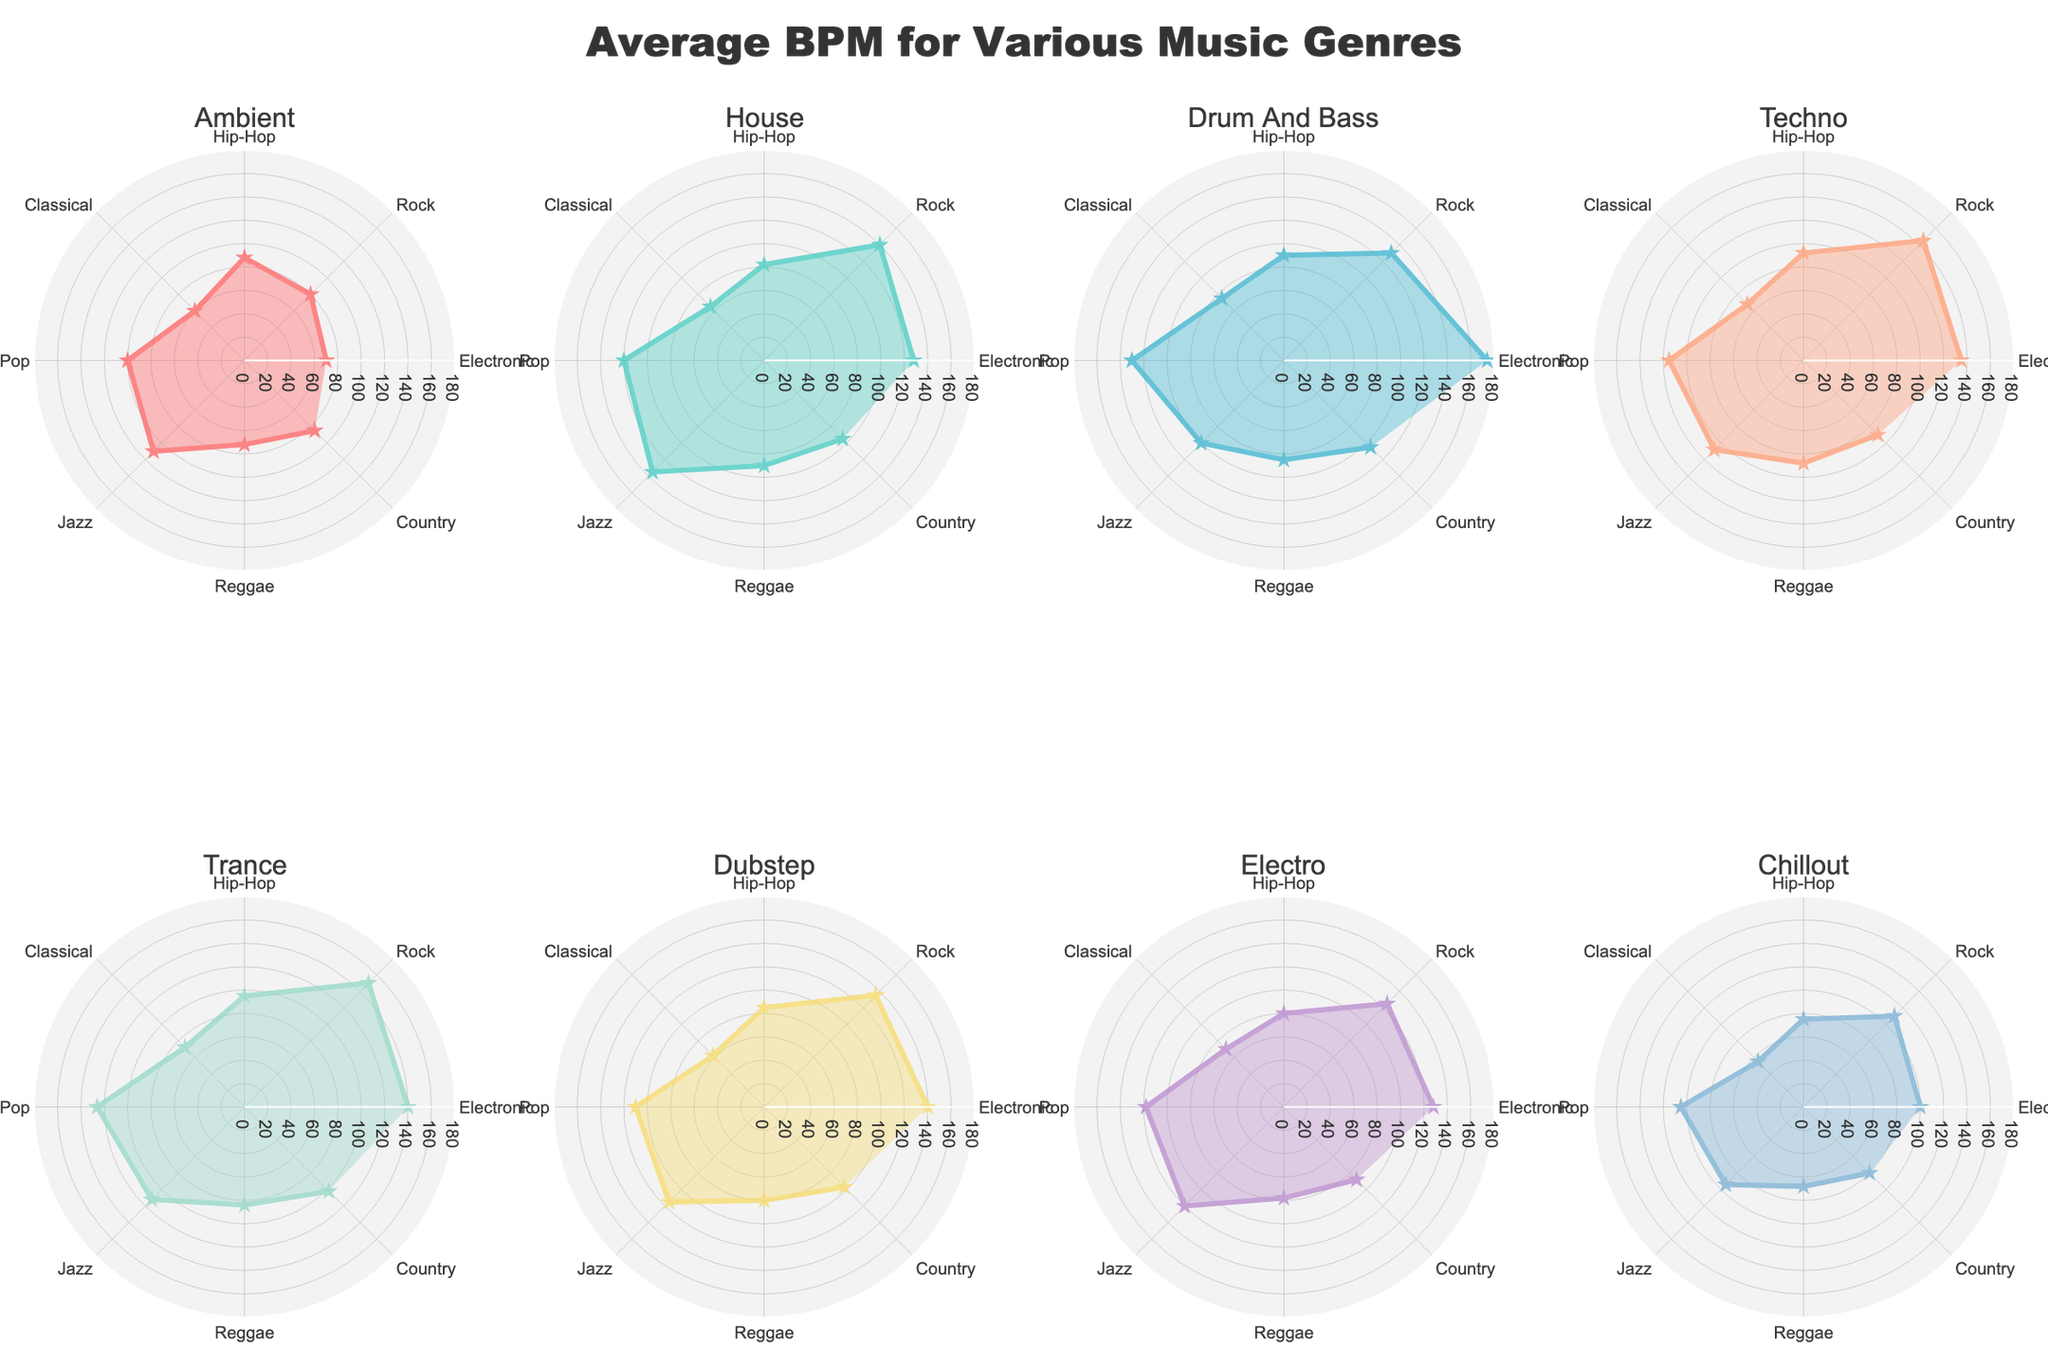Which genre has the highest average BPM for the Electronic category? Look at the Electronic category across all subplots and identify the highest BPM. Trance has the highest value at 140 BPM.
Answer: Trance Which genre has the lowest BPM in the Classical category? Look at the Classical category across all subplots and identify the lowest BPM. Chillout has the lowest BPM at 55.
Answer: Chillout How does the BPM of House in the Pop category compare to Dubstep in the same category? Check the BPM values for House and Dubstep in the Pop category. House has a BPM of 120, and Dubstep has a BPM of 110. 120 is greater than 110.
Answer: House has a higher BPM than Dubstep What's the average BPM of Jazz across all genres? Sum up all the BPM values for Jazz across the genres and divide by the number of genres (8). The sum is 110 + 135 + 100 + 108 + 112 + 115 + 120 + 94 = 894. The average is 894 / 8 = 111.75.
Answer: 111.75 Which genre shows the most significant variation in BPM among different music categories? Compare the BPM ranges (max - min BPM) for each genre across various categories. Drum And Bass ranges from 75 to 174, a difference of 99 BPM.
Answer: Drum And Bass In which category does Techno have the highest BPM? Check the BPM values for Techno across all categories. Rock has the highest BPM for Techno at 145.
Answer: Rock If you wanted a soundtrack with a moderate BPM around 100-110, which genres and categories would you consider? Identify BPM values between 100 and 110 across all categories and genres. Ambient (Pop), House (Pop), Chillout (Pop), Electro (Pop), Jazz (Electronic and Rock), Electro (Rock and Classical) fit this range.
Answer: Ambient (Pop), House (Pop), Chillout (Pop), Electro (Pop), Jazz (Electronic, Rock), Electro (Rock, Classical) Which genre is consistently below 90 BPM across all categories? Check each genre's BPM across all categories to find consistent values below 90 BPM. Chillout meets this criterion.
Answer: Chillout 